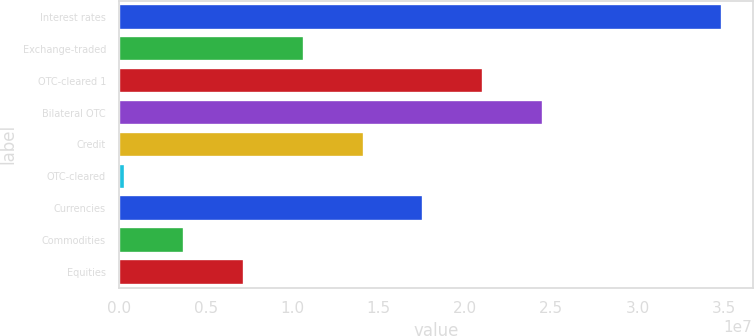<chart> <loc_0><loc_0><loc_500><loc_500><bar_chart><fcel>Interest rates<fcel>Exchange-traded<fcel>OTC-cleared 1<fcel>Bilateral OTC<fcel>Credit<fcel>OTC-cleared<fcel>Currencies<fcel>Commodities<fcel>Equities<nl><fcel>3.48918e+07<fcel>1.06804e+07<fcel>2.10567e+07<fcel>2.45155e+07<fcel>1.41392e+07<fcel>304100<fcel>1.75979e+07<fcel>3.76287e+06<fcel>7.22163e+06<nl></chart> 